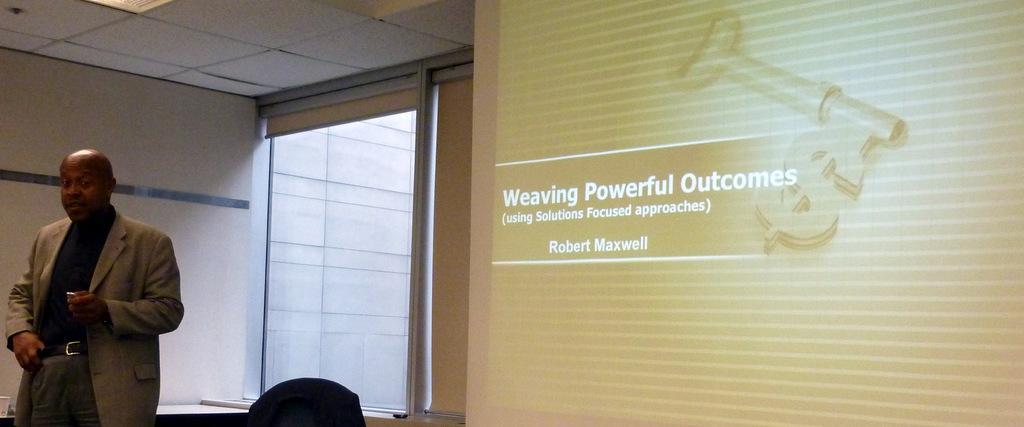Please provide a concise description of this image. In the image, a man is giving a presentation. There is presentation screen behind him and something is being projected on that screen,the person is talking something and he is wearing a blazer and behind a person there is a window and in the left side of the window there is a wall. 